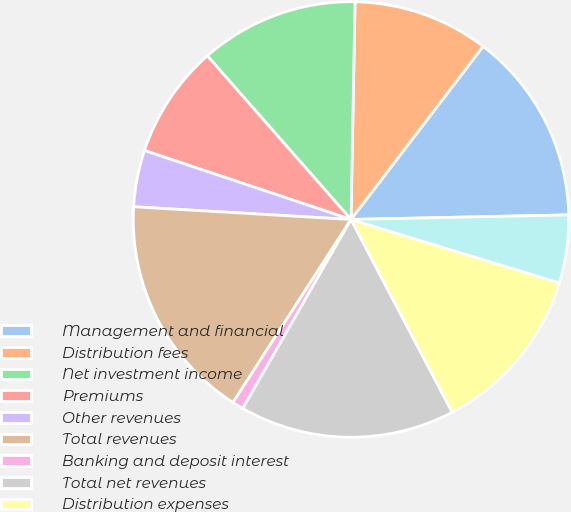Convert chart. <chart><loc_0><loc_0><loc_500><loc_500><pie_chart><fcel>Management and financial<fcel>Distribution fees<fcel>Net investment income<fcel>Premiums<fcel>Other revenues<fcel>Total revenues<fcel>Banking and deposit interest<fcel>Total net revenues<fcel>Distribution expenses<fcel>Interest credited to fixed<nl><fcel>14.29%<fcel>10.08%<fcel>11.76%<fcel>8.4%<fcel>4.2%<fcel>16.81%<fcel>0.84%<fcel>15.97%<fcel>12.6%<fcel>5.04%<nl></chart> 